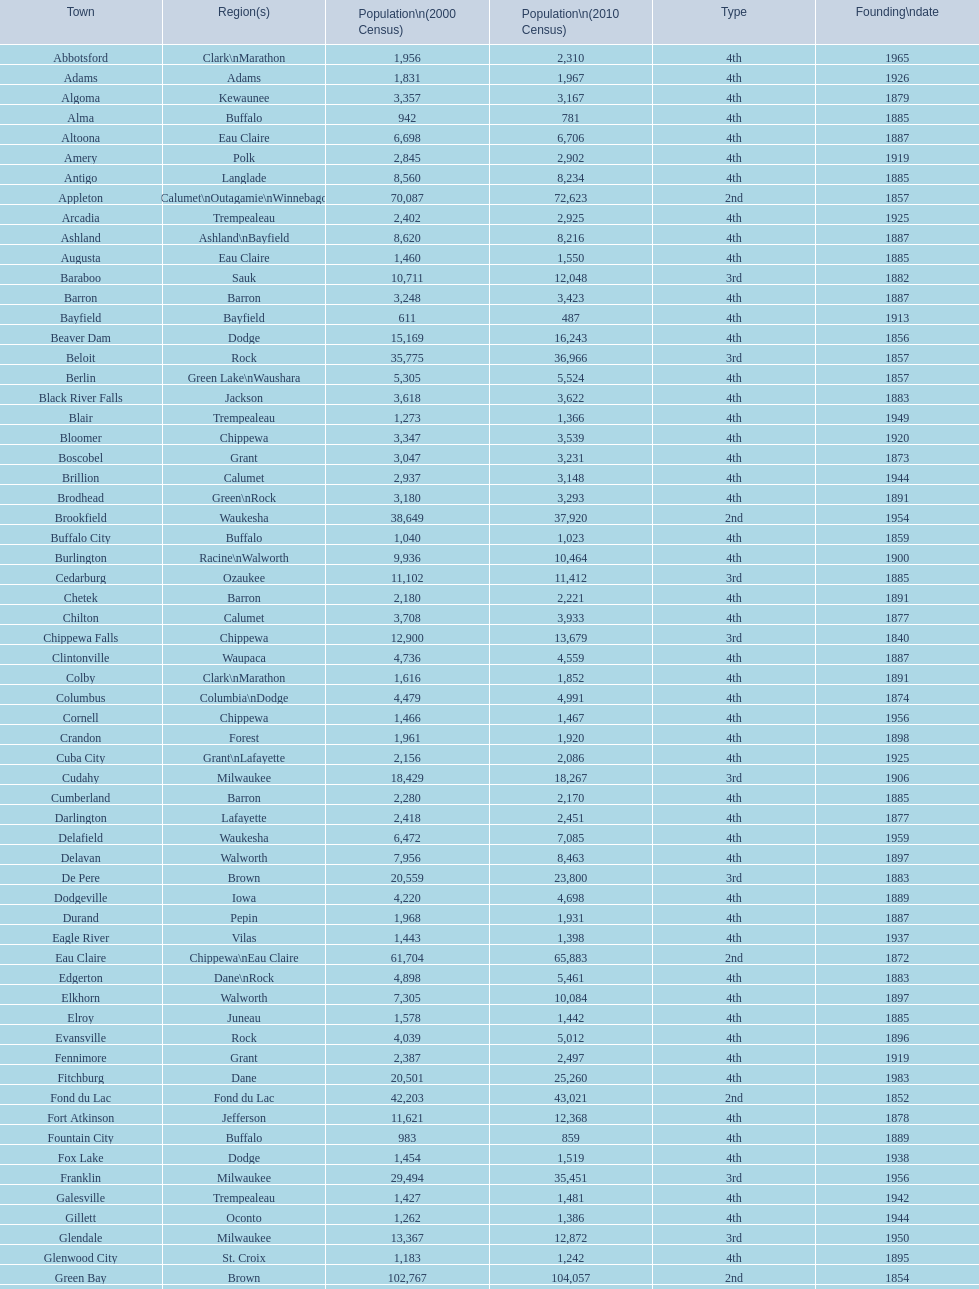County has altoona and augusta? Eau Claire. 